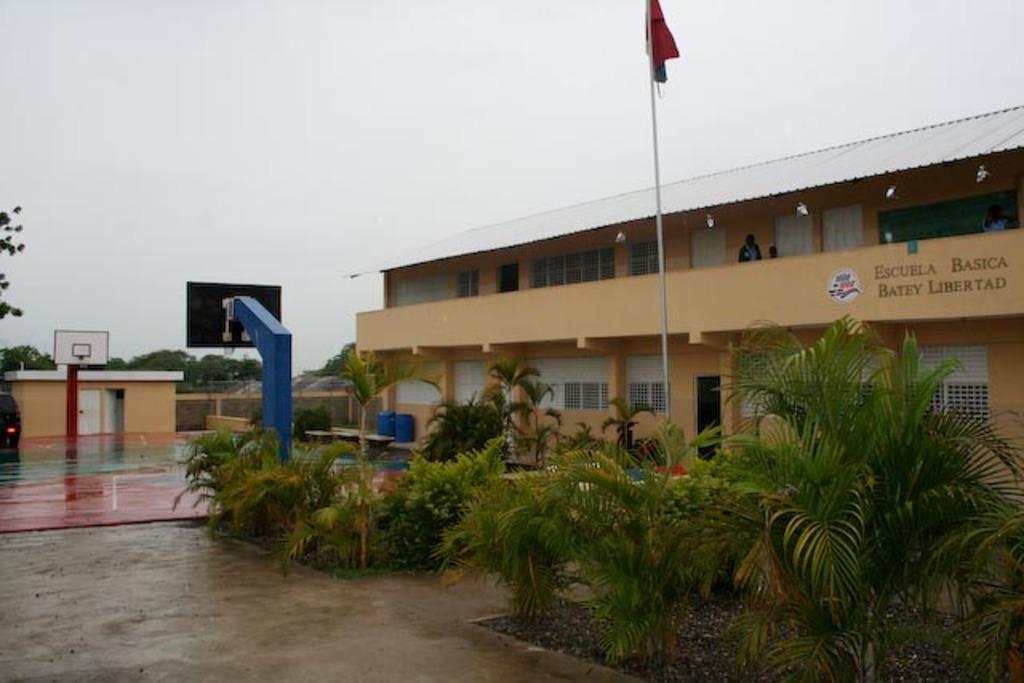How would you summarize this image in a sentence or two? In the image there is a building and in front of the building there is a basketball court, plants and a flag. 